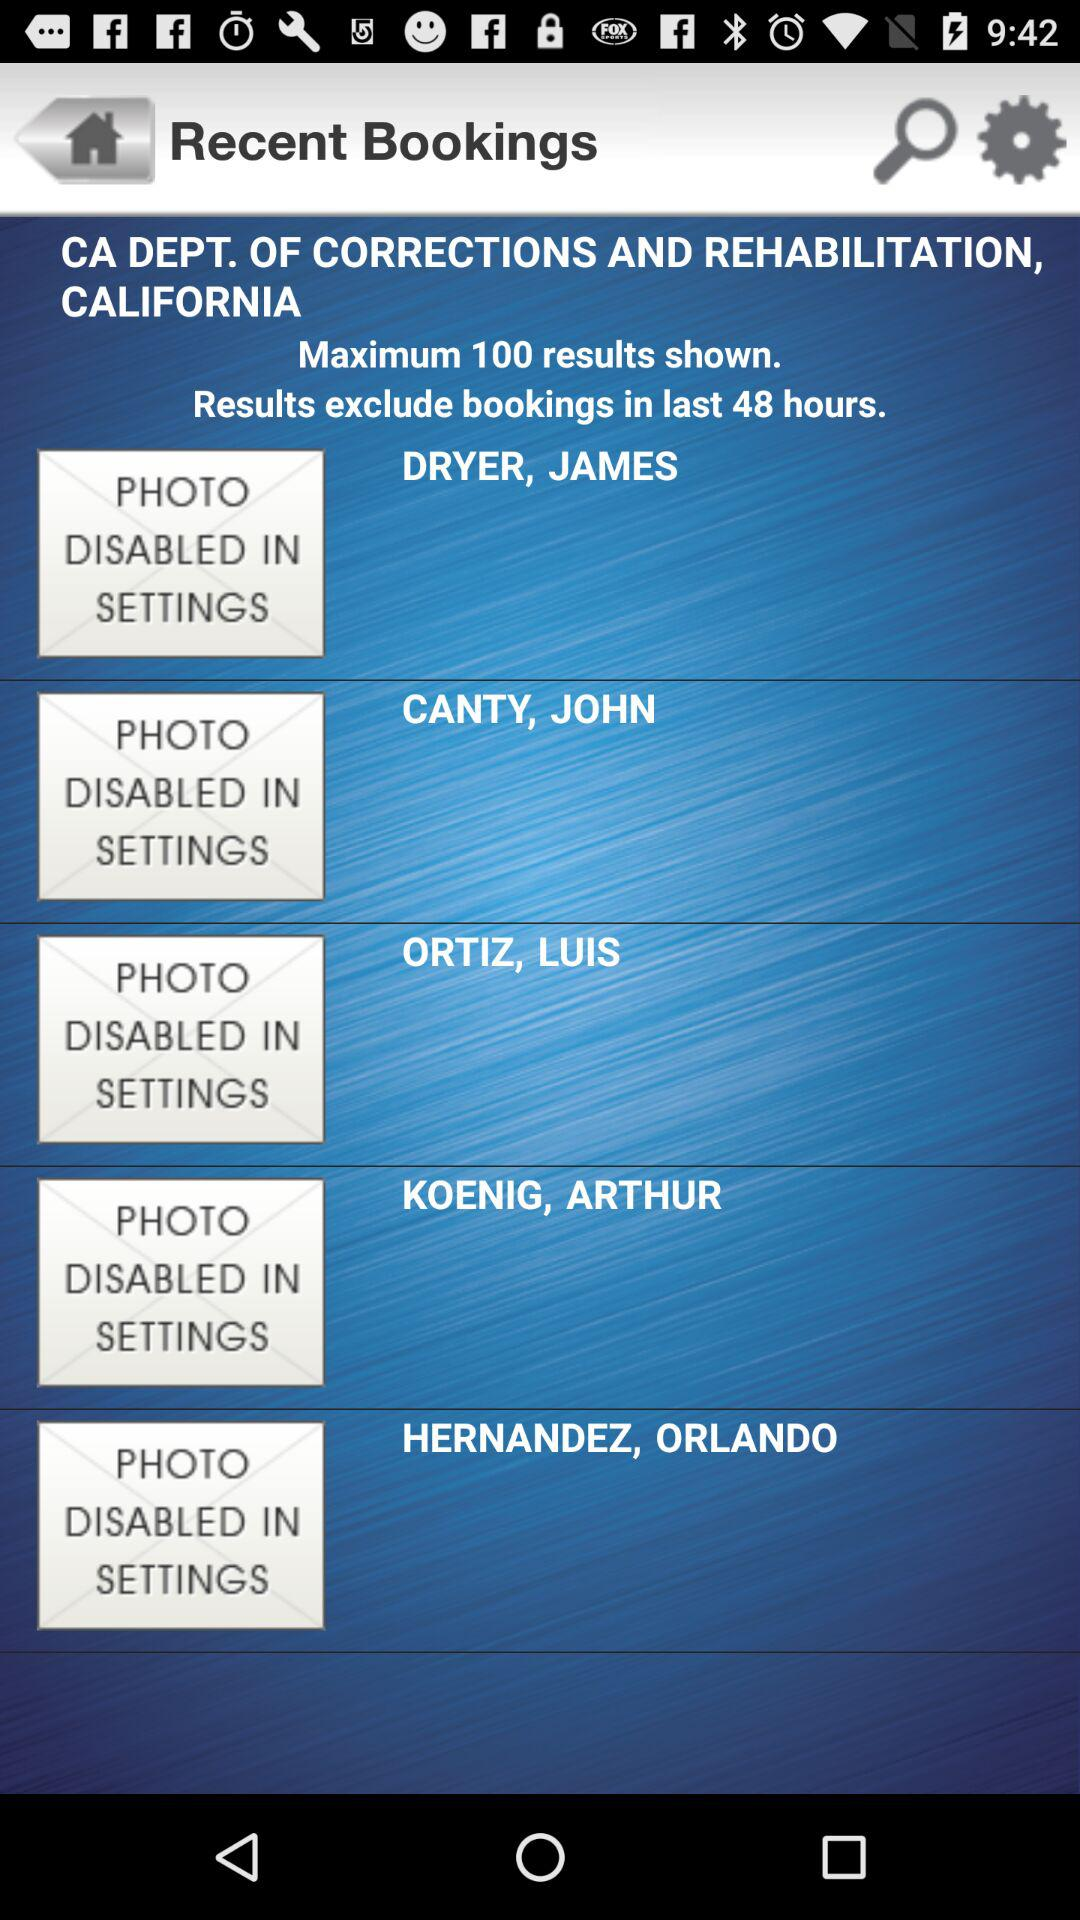How many of the maximum results are shown? The maximum results shown are 100. 